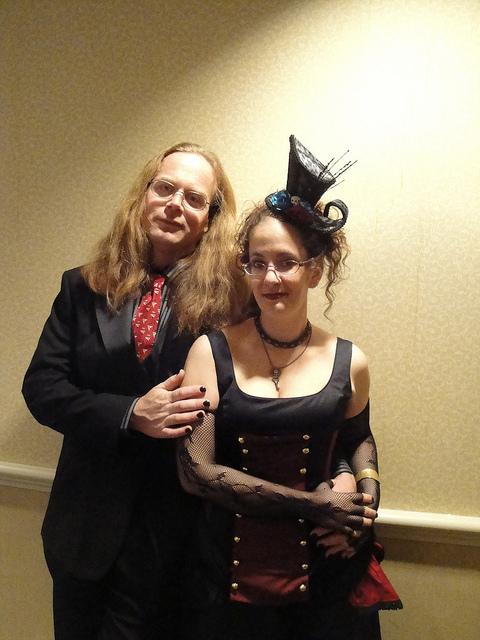What is on the woman's head?
Concise answer only. Hat. Is there a shoulder strap?
Give a very brief answer. Yes. Do these people look like a couple?
Quick response, please. Yes. Is the person on the left a man or a woman?
Quick response, please. Man. 